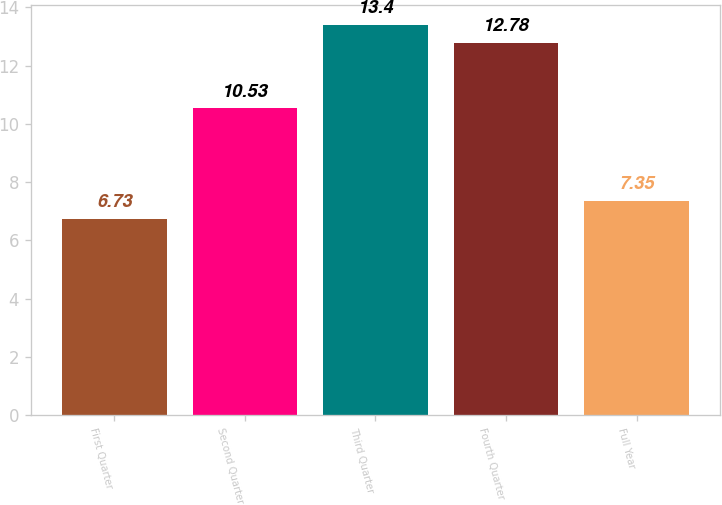<chart> <loc_0><loc_0><loc_500><loc_500><bar_chart><fcel>First Quarter<fcel>Second Quarter<fcel>Third Quarter<fcel>Fourth Quarter<fcel>Full Year<nl><fcel>6.73<fcel>10.53<fcel>13.4<fcel>12.78<fcel>7.35<nl></chart> 